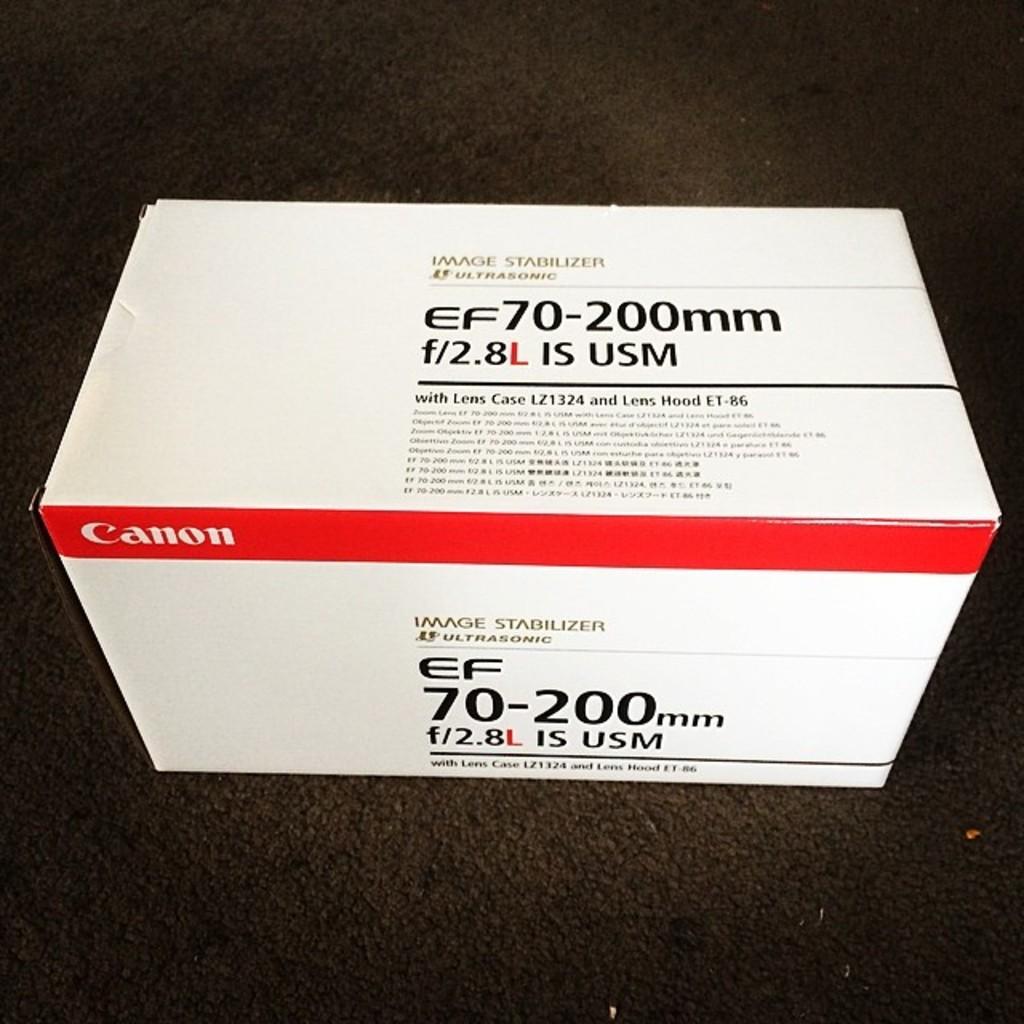What is the mm on this camera?
Give a very brief answer. 70-200. What brand it is?
Offer a terse response. Canon. 